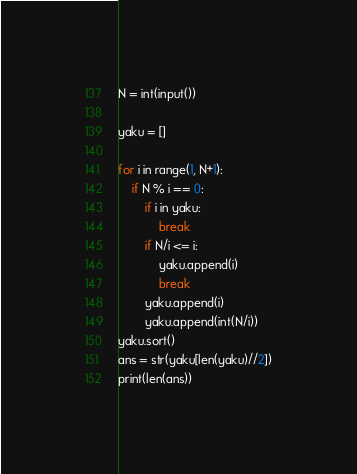Convert code to text. <code><loc_0><loc_0><loc_500><loc_500><_Python_>N = int(input())

yaku = []

for i in range(1, N+1):
    if N % i == 0:
        if i in yaku:
            break
        if N/i <= i:
            yaku.append(i)
            break
        yaku.append(i)
        yaku.append(int(N/i))
yaku.sort()
ans = str(yaku[len(yaku)//2])
print(len(ans))
</code> 